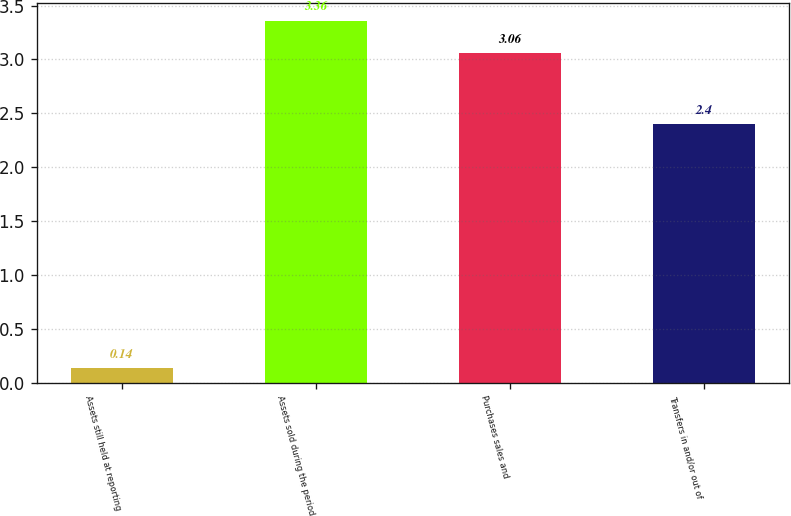<chart> <loc_0><loc_0><loc_500><loc_500><bar_chart><fcel>Assets still held at reporting<fcel>Assets sold during the period<fcel>Purchases sales and<fcel>Transfers in and/or out of<nl><fcel>0.14<fcel>3.36<fcel>3.06<fcel>2.4<nl></chart> 